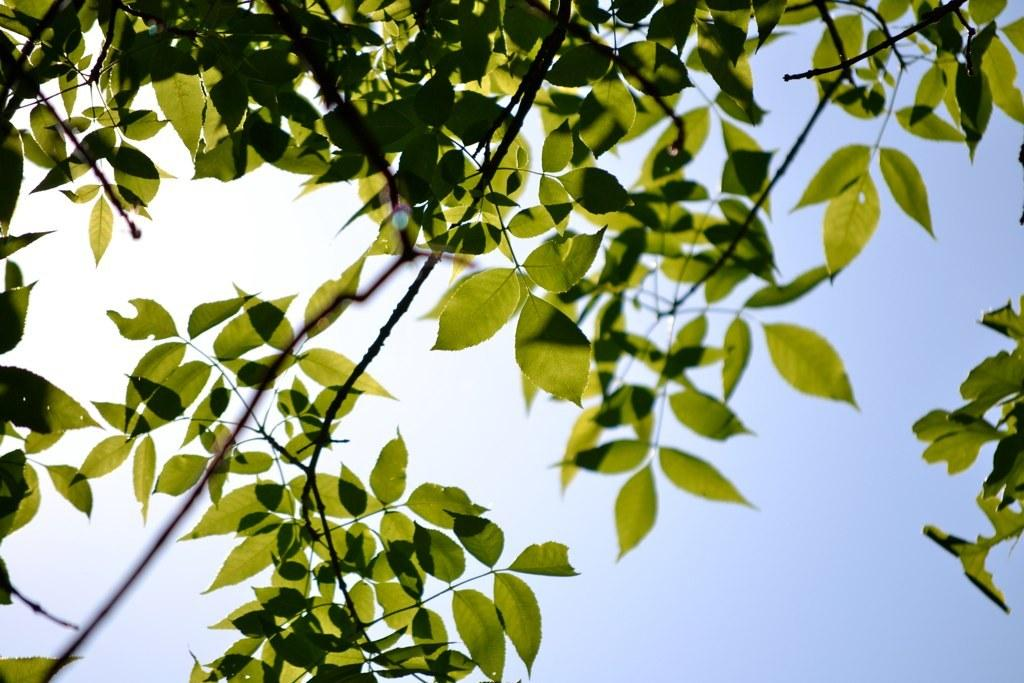What can be seen at the top of the image? The sky is visible in the image. What type of vegetation is present in the image? Leaves and stems are visible in the image. What type of sack can be seen in the image? There is no sack present in the image. What discovery was made using a calculator in the image? There is no discovery or calculator present in the image. 